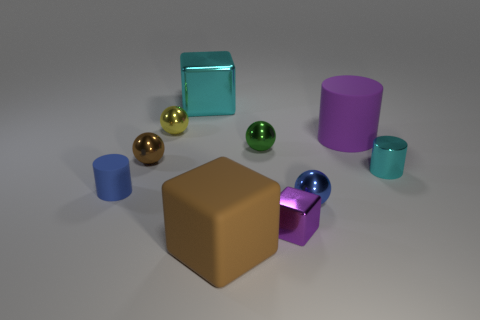Subtract all cyan balls. Subtract all blue cylinders. How many balls are left? 4 Subtract all cylinders. How many objects are left? 7 Add 9 big brown objects. How many big brown objects are left? 10 Add 6 big cyan objects. How many big cyan objects exist? 7 Subtract 1 blue balls. How many objects are left? 9 Subtract all cyan metal blocks. Subtract all big rubber objects. How many objects are left? 7 